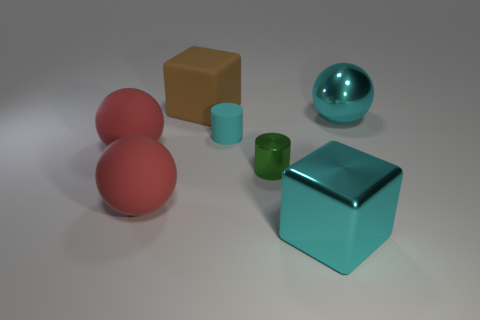Is the green object made of the same material as the small cylinder on the left side of the green metal cylinder?
Offer a terse response. No. What color is the cube on the left side of the large cyan shiny thing that is in front of the big sphere that is to the right of the large matte block?
Make the answer very short. Brown. The metallic thing that is the same size as the metallic ball is what shape?
Make the answer very short. Cube. Does the cube to the right of the tiny cyan cylinder have the same size as the rubber object behind the shiny sphere?
Your answer should be very brief. Yes. There is a object right of the large cyan shiny block; what is its size?
Provide a succinct answer. Large. What is the material of the big block that is the same color as the small matte thing?
Ensure brevity in your answer.  Metal. There is a thing that is the same size as the matte cylinder; what is its color?
Keep it short and to the point. Green. Does the green thing have the same size as the brown matte thing?
Provide a short and direct response. No. What is the size of the object that is on the left side of the small green metal cylinder and right of the large brown cube?
Your response must be concise. Small. How many metal objects are tiny green objects or big cyan things?
Make the answer very short. 3. 